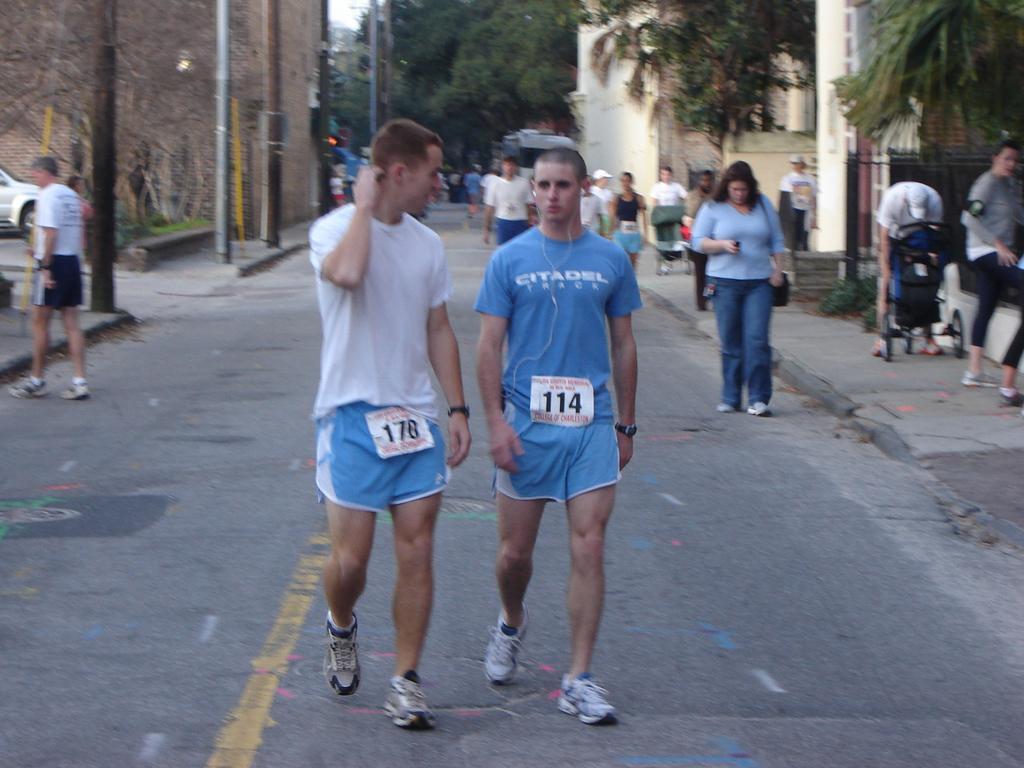Describe this image in one or two sentences. In this image, there are a few people. We can see some trees, poles. We can see some lights. We can see the ground. We can see a vehicle on the left. We can also see a few baby trolleys. We can also see the fence. 